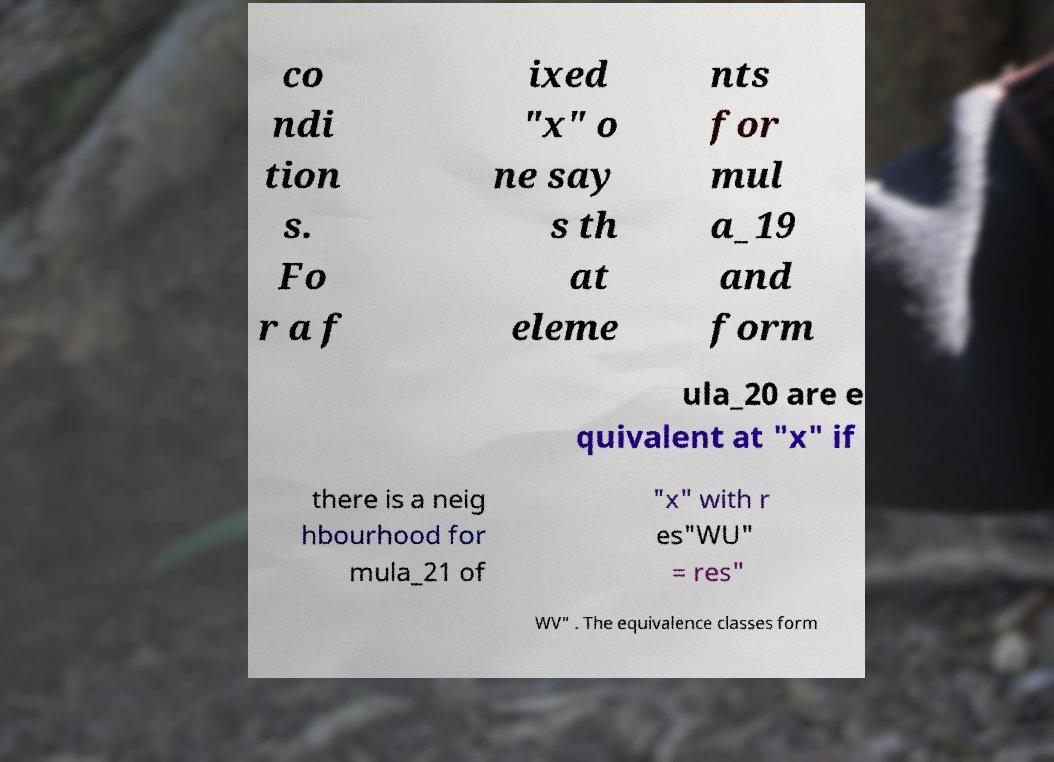Can you read and provide the text displayed in the image?This photo seems to have some interesting text. Can you extract and type it out for me? co ndi tion s. Fo r a f ixed "x" o ne say s th at eleme nts for mul a_19 and form ula_20 are e quivalent at "x" if there is a neig hbourhood for mula_21 of "x" with r es"WU" = res" WV" . The equivalence classes form 